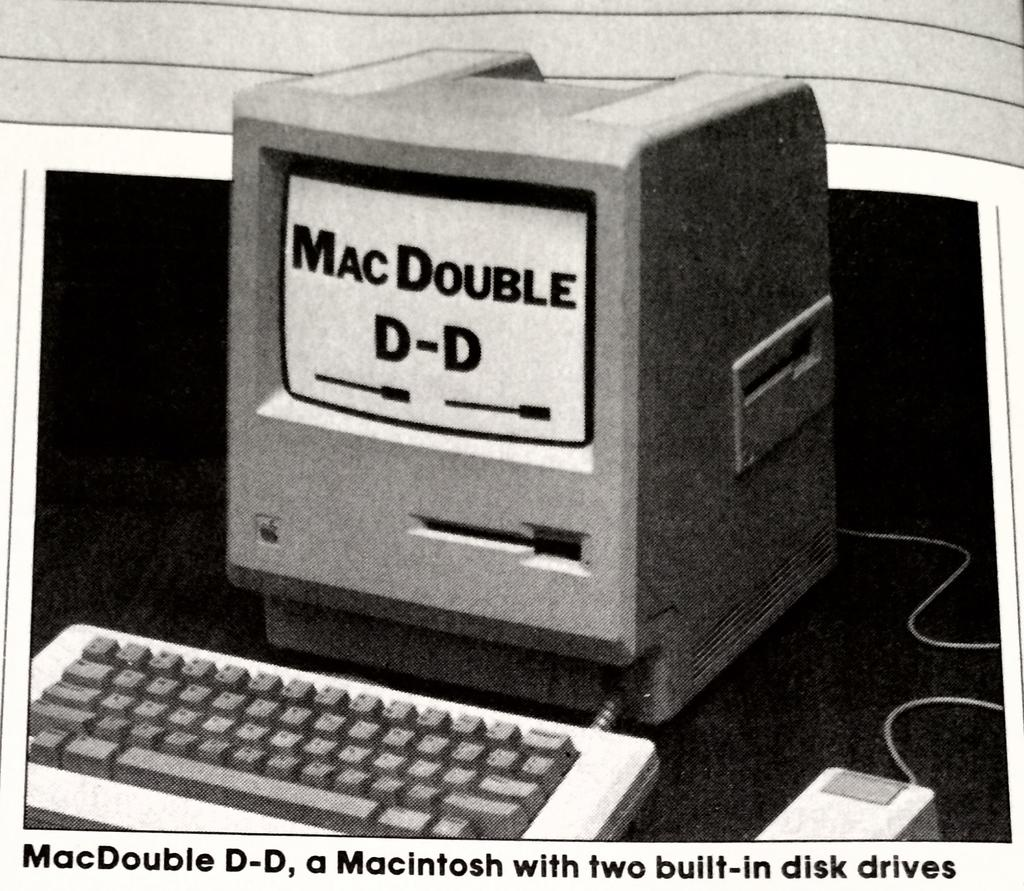Provide a one-sentence caption for the provided image. An old computer with the words "MacDOuble D-D" on the screen. 